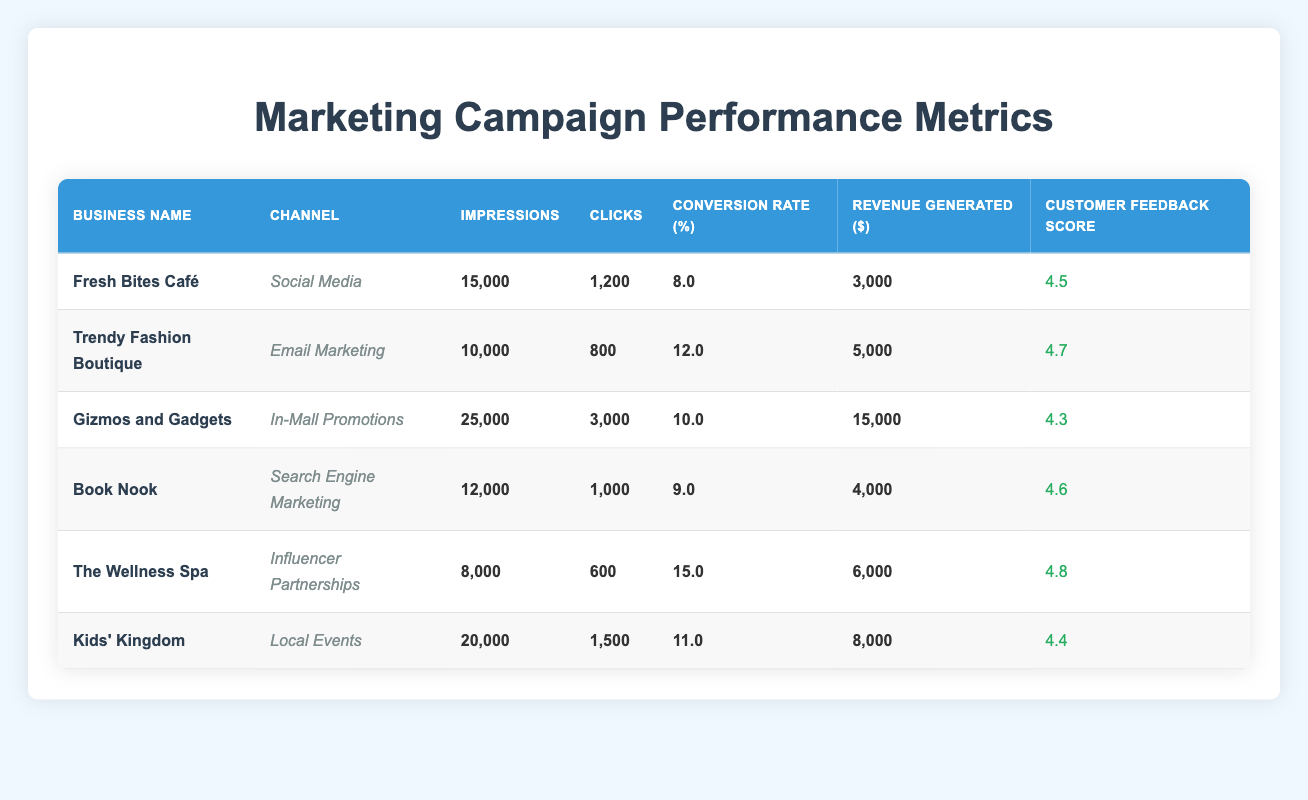What is the total revenue generated by "Gizmos and Gadgets"? The revenue generated by "Gizmos and Gadgets" is listed in the table as $15,000.
Answer: $15,000 Which business had the highest conversion rate and what was that rate? The highest conversion rate in the table is associated with "The Wellness Spa," which has a conversion rate of 15.0%.
Answer: 15.0% How many clicks did "Kids’ Kingdom" receive? According to the table, "Kids’ Kingdom" received 1,500 clicks.
Answer: 1,500 What is the average customer feedback score across all businesses listed? To find the average score, sum up all customer feedback scores (4.5 + 4.7 + 4.3 + 4.6 + 4.8 + 4.4 = 27.3) and divide by the number of businesses (6), resulting in an average score of 27.3/6 = 4.55.
Answer: 4.55 Is "Fresh Bites Café" performing better than "Book Nook" in terms of revenue generated? "Fresh Bites Café" generated $3,000, while "Book Nook" generated $4,000. Since $3,000 is less than $4,000, "Fresh Bites Café" is not performing better.
Answer: No Which marketing channel provided the most impressions overall? The impressions for each channel are: Social Media (15,000), Email Marketing (10,000), In-Mall Promotions (25,000), Search Engine Marketing (12,000), Influencer Partnerships (8,000), Local Events (20,000). The largest number is from In-Mall Promotions with 25,000 impressions.
Answer: In-Mall Promotions What is the difference in clicks between "Trendy Fashion Boutique" and "The Wellness Spa"? "Trendy Fashion Boutique" received 800 clicks while "The Wellness Spa" received 600 clicks. The difference is 800 - 600 = 200 clicks, meaning "Trendy Fashion Boutique" had 200 more clicks.
Answer: 200 clicks Did any business generate less than $4,000 in revenue? Looking at the revenue figures, "Fresh Bites Café" generated $3,000, which is less than $4,000, confirming that at least one business did indeed generate less.
Answer: Yes What is the average conversion rate for businesses that used social media and influencer partnerships? The conversion rates for these channels are: "Fresh Bites Café" (8.0%) for Social Media and "The Wellness Spa" (15.0%) for Influencer Partnerships. The average is (8.0 + 15.0)/2 = 11.5%.
Answer: 11.5% 